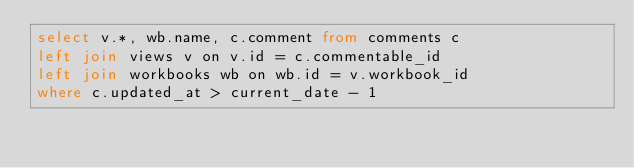Convert code to text. <code><loc_0><loc_0><loc_500><loc_500><_SQL_>select v.*, wb.name, c.comment from comments c
left join views v on v.id = c.commentable_id
left join workbooks wb on wb.id = v.workbook_id
where c.updated_at > current_date - 1
</code> 